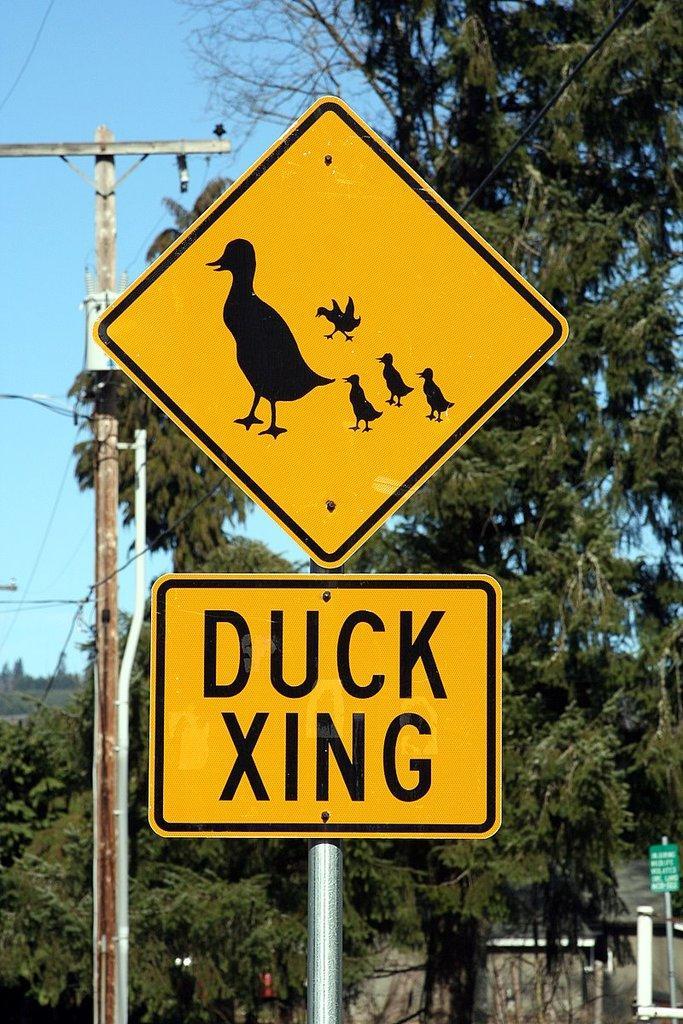In one or two sentences, can you explain what this image depicts? In the center of the image there is a sign board. In the background we can see pole, trees and sky. 